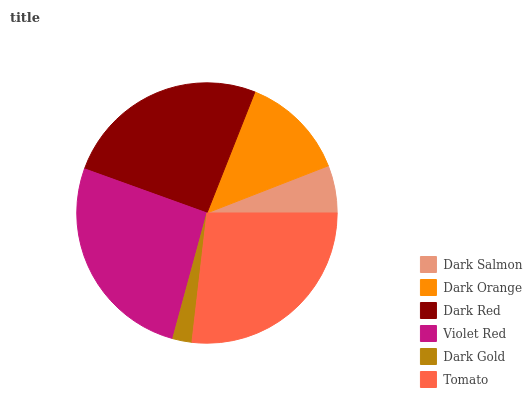Is Dark Gold the minimum?
Answer yes or no. Yes. Is Tomato the maximum?
Answer yes or no. Yes. Is Dark Orange the minimum?
Answer yes or no. No. Is Dark Orange the maximum?
Answer yes or no. No. Is Dark Orange greater than Dark Salmon?
Answer yes or no. Yes. Is Dark Salmon less than Dark Orange?
Answer yes or no. Yes. Is Dark Salmon greater than Dark Orange?
Answer yes or no. No. Is Dark Orange less than Dark Salmon?
Answer yes or no. No. Is Dark Red the high median?
Answer yes or no. Yes. Is Dark Orange the low median?
Answer yes or no. Yes. Is Tomato the high median?
Answer yes or no. No. Is Tomato the low median?
Answer yes or no. No. 